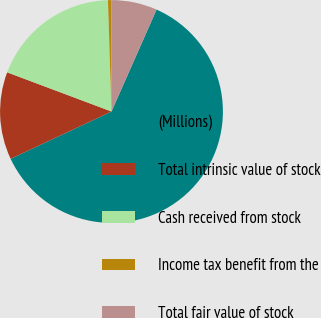Convert chart to OTSL. <chart><loc_0><loc_0><loc_500><loc_500><pie_chart><fcel>(Millions)<fcel>Total intrinsic value of stock<fcel>Cash received from stock<fcel>Income tax benefit from the<fcel>Total fair value of stock<nl><fcel>61.39%<fcel>12.7%<fcel>18.78%<fcel>0.52%<fcel>6.61%<nl></chart> 